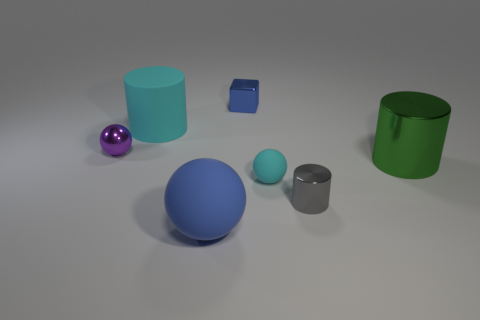Add 1 large cyan rubber cylinders. How many objects exist? 8 Subtract all balls. How many objects are left? 4 Subtract all gray metallic objects. Subtract all large things. How many objects are left? 3 Add 6 big green objects. How many big green objects are left? 7 Add 7 tiny blue things. How many tiny blue things exist? 8 Subtract 0 red cubes. How many objects are left? 7 